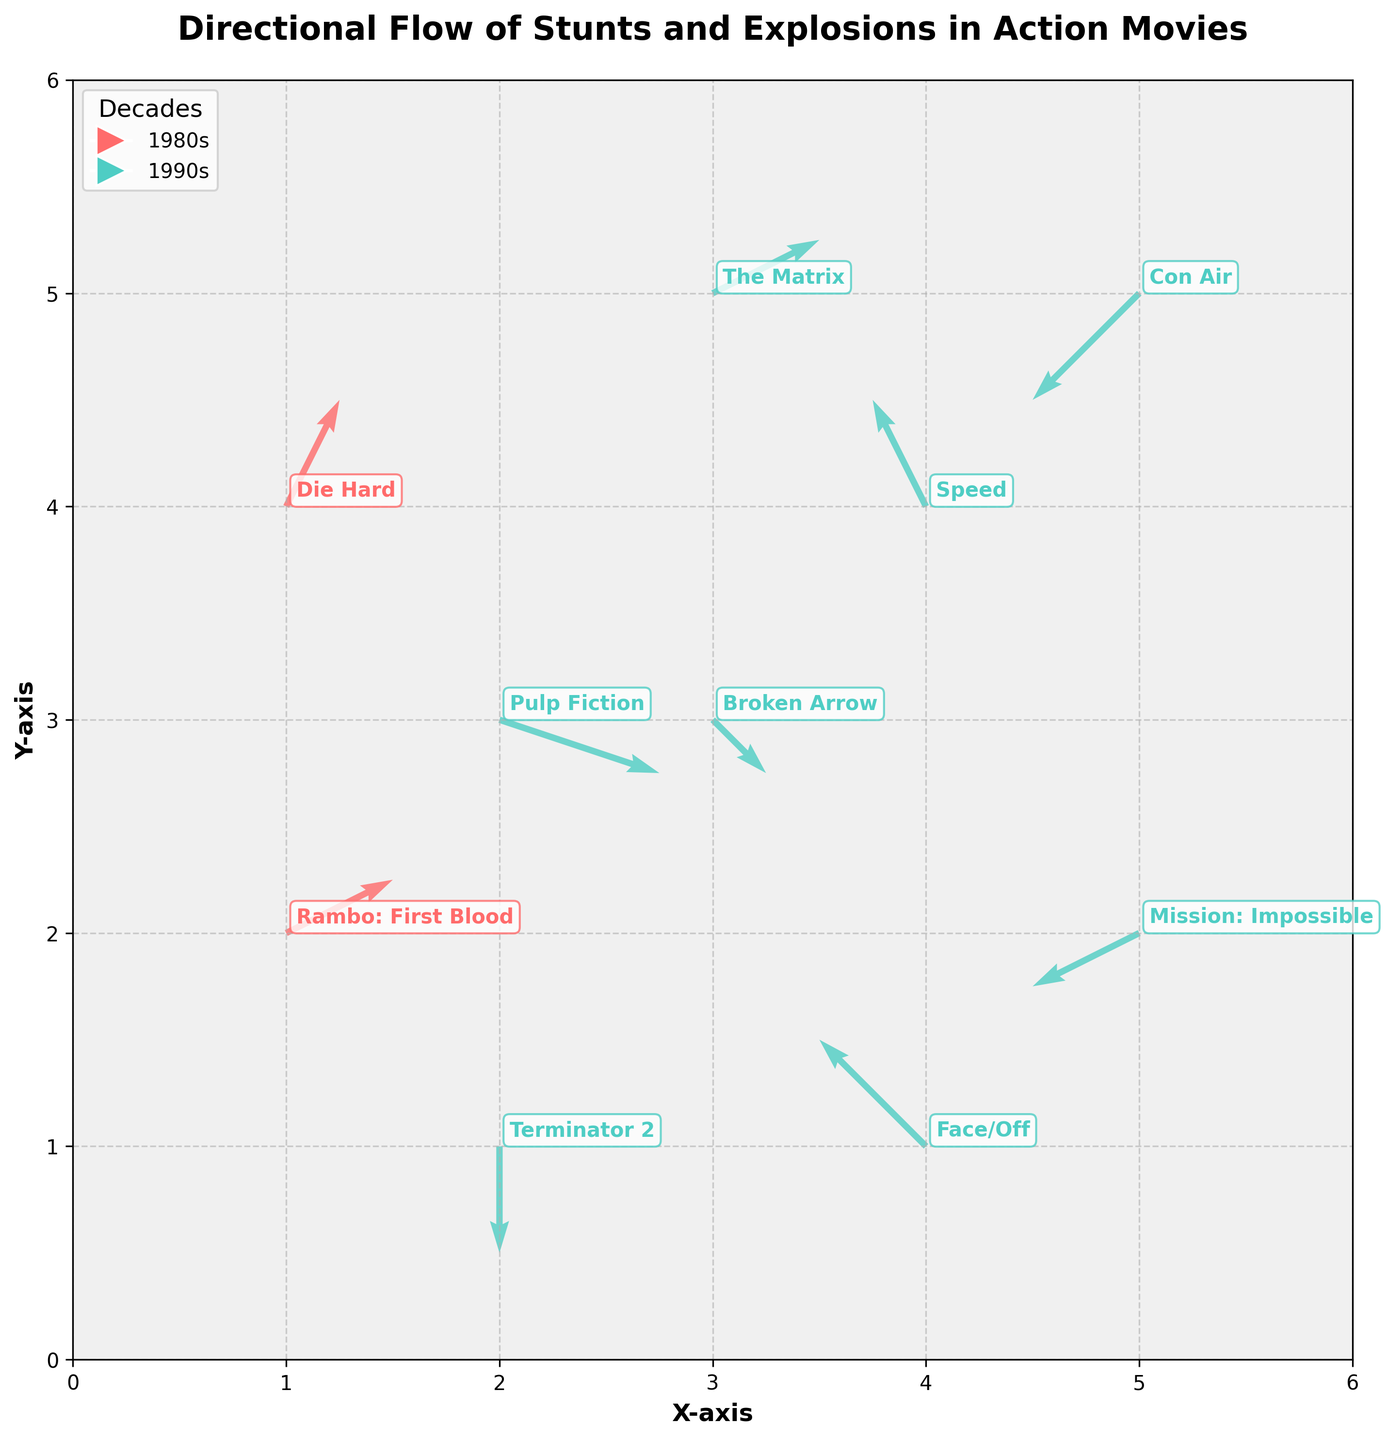What is the title of the plot? The title of the plot is mentioned at the top center of the figure. It is displayed prominently in bold and larger font size than other text.
Answer: Directional Flow of Stunts and Explosions in Action Movies What are the colors used to represent different decades in the plot? The plot uses distinct colors to differentiate between decades. The legend on the upper left indicates these colors.
Answer: Red and Teal Which movie in the 1990s has the highest upward directional flow? To determine the movie with the highest upward directional flow, look for the longest arrow with the largest component in the positive y-direction (v). Among the 1990s movies, The Matrix has the highest upward flow (v = 0.5).
Answer: The Matrix How many data points are there for movies from the 1980s? Count the number of points (arrows) labeled with movies from the 1980s. This can be seen by tallying the movie annotations and arrows in red.
Answer: 2 Between "Pulp Fiction" and "Speed," which movie has a stronger horizontal component of the directional flow? Compare the horizontal components (u) of these movies. "Pulp Fiction" has u = 1.5 while "Speed" has u = -0.5. Therefore, "Pulp Fiction" has a stronger horizontal component.
Answer: Pulp Fiction What is the average horizontal component (u) of the directional flows for all 1990s movies? Calculate the average by summing up the u-values of all 1990s movies and dividing by their quantity: (1.5 + (-1) + (-1) + 1 + 0 + (-0.5) + 0.5 - 1) / 8 = -0.0625
Answer: -0.0625 Which movie from the 1980s has the greater magnitude of directional flow? Calculate the magnitude (sqrt(u^2 + v^2)) for each 1980s movie and compare: "Die Hard" (sqrt(0.5^2 + 1^2) ~ 1.12) and "Rambo: First Blood" (sqrt(1^2 + 0.5^2) ~ 1.12). They are the same in this case.
Answer: Both have equal magnitudes Among the listed movies, which one does not have any movement in the horizontal direction (x-axis)? Look for a movie with a horizontal component (u) equal to zero. The plot shows "Terminator 2" with u = 0.
Answer: Terminator 2 Which movie shows a directional flow that moves diagonally downward and to the left? Identify the movie with negative u and v values. "Con Air" has both u = -1 and v = -1, indicating diagonally downward and left movement.
Answer: Con Air 